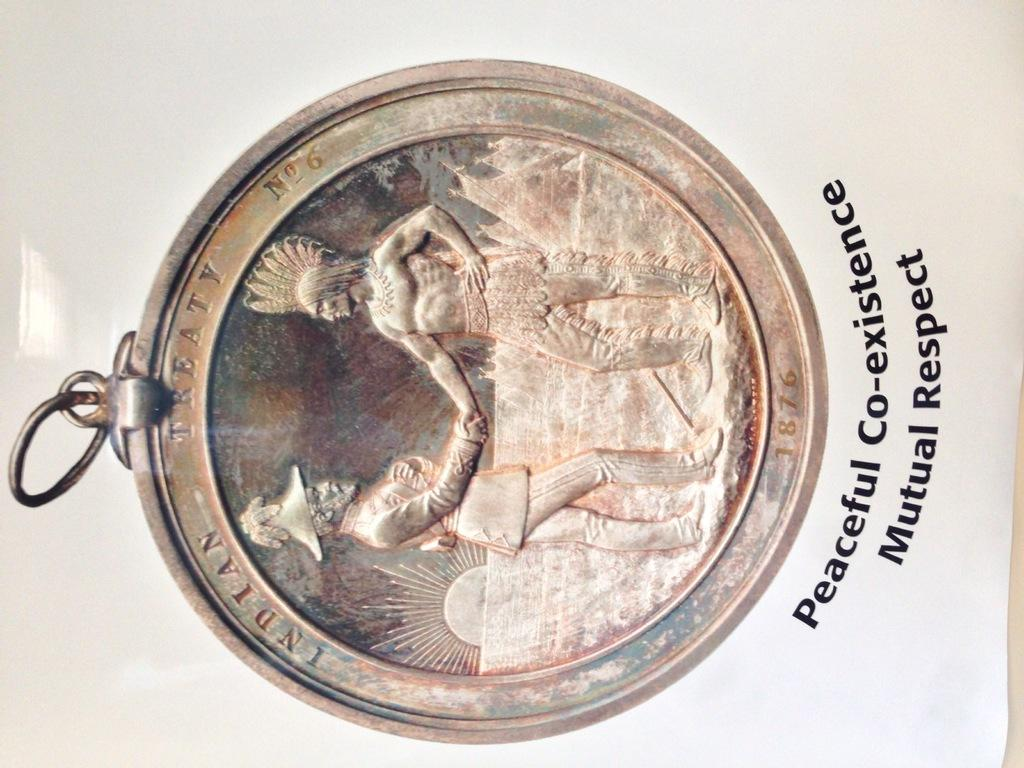Provide a one-sentence caption for the provided image. the word treaty is at the top of a coin. 